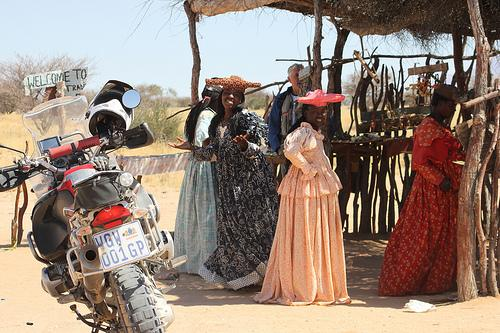Talk about the environment where the motorcycle is parked. The motorcycle is parked on a dirt ground with a white welcome sign posted nearby, surrounded by women wearing long dresses and hats. Rewrite the description with a focus on the women in the image. A group of women, dressed to impress with their long, flowing dresses, and delightful hats, stand next to a parked motorcycle, as a white welcome sign beckons the passersby. Provide a brief summary of the main highlights in the image. A motorcycle is parked on dirt ground, with a group of women in long dresses and hats nearby, and a white welcome sign is seen by the side. Explain the most eye-catching element in the image. The black motorcycle with red handlebars parked on dirt ground is the most eye-catching element of the image, with several features like license plate and taillight. Describe the people in the image and their attire. There are women wearing long dresses and hats in various colors, such as red, black and white, peach, and blue, with some having ribbons in their hair. Describe the scene happening in the image with a touch of humor. A motorcycle throwing a parking party for itself with lovely ladies in long dresses and hats to match, and a cute welcome sign have come together for a celebration. Give a dramatic description of the scene in the image. Amidst the gathering of elegant ladies in colorful long dresses and hats, a black motorcycle stands out with red handlebars on the dusty ground, while a welcome sign urges onlookers to join the party. Provide a minimalist description of the image. Parked motorcycle, women in long dresses with hats, white welcome sign. Describe the image as if you were writing a brief postcard message. Wish you were here! A captivating scene with a stylish parked motorcycle and charming ladies in long dresses and hats gathered around it. Greetings from the welcome sign too! Mention the core object of the image and its features. A black motorcycle with red handlebars and a blue and white license plate is parked on the ground, with a taillight and a windshield. 